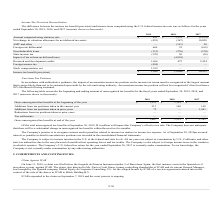According to Mitek Systems's financial document, What does the table show us? The difference between the income tax benefit (provision) and income taxes computed using the U.S. federal income tax rate. The document states: "The difference between the income tax benefit (provision) and income taxes computed using the U.S. federal income tax rate was as follows for the year..." Also, What are the income tax benefits (provision), for the fiscal years 2017, 2018, and 2019, respectively? The document contains multiple relevant values: $10,921, $(3,066), $3,264 (in thousands). From the document: "Income tax benefit (provision) $ 3,264 $ (3,066) $ 10,921 ncome tax benefit (provision) $ 3,264 $ (3,066) $ 10,921 Income tax benefit (provision) $ 3,..." Also, What are state income tax for the years 2018 and 2019, respectively? The document shows two values: 50 and (370) (in thousands). From the document: "State income tax (370) 50 (34) State income tax (370) 50 (34)..." Additionally, Which year has the highest income tax benefit?  According to the financial document, 2017. The relevant text states: "2019 2018 2017..." Also, can you calculate: What is the sum of amount computed using statutory rate and foreign rate differential in 2018 as a percentage of 2019? To answer this question, I need to perform calculations using the financial data. The calculation is: (2,122+22)/(841+664) , which equals 1.42. This is based on the information: "Amount computed using statutory rate $ 841 $ 2,122 $ (1,078) Amount computed using statutory rate $ 841 $ 2,122 $ (1,078) Foreign rate differential 664 22 (169) Amount computed using statutory rate $ ..." The key data points involved are: 2,122, 22, 664. Also, can you calculate: What is the percentage change in research and development credits from 2018 to 2019? To answer this question, I need to perform calculations using the financial data. The calculation is: (1,694-475)/475 , which equals 256.63 (percentage). This is based on the information: "Research and development credits 1,694 475 2,494 Research and development credits 1,694 475 2,494..." The key data points involved are: 1,694, 475. 